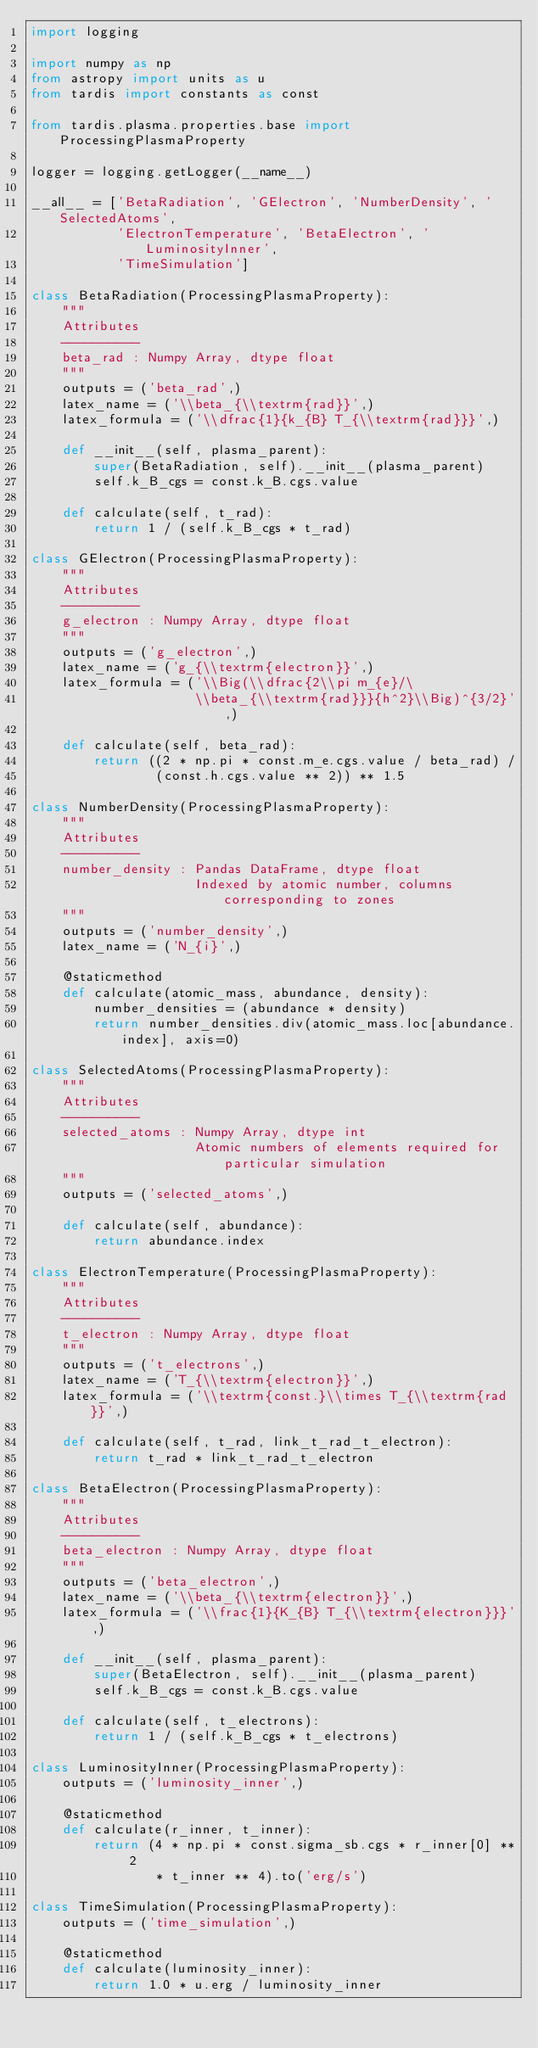<code> <loc_0><loc_0><loc_500><loc_500><_Python_>import logging

import numpy as np
from astropy import units as u
from tardis import constants as const

from tardis.plasma.properties.base import ProcessingPlasmaProperty

logger = logging.getLogger(__name__)

__all__ = ['BetaRadiation', 'GElectron', 'NumberDensity', 'SelectedAtoms',
           'ElectronTemperature', 'BetaElectron', 'LuminosityInner',
           'TimeSimulation']

class BetaRadiation(ProcessingPlasmaProperty):
    """
    Attributes
    ----------
    beta_rad : Numpy Array, dtype float
    """
    outputs = ('beta_rad',)
    latex_name = ('\\beta_{\\textrm{rad}}',)
    latex_formula = ('\\dfrac{1}{k_{B} T_{\\textrm{rad}}}',)

    def __init__(self, plasma_parent):
        super(BetaRadiation, self).__init__(plasma_parent)
        self.k_B_cgs = const.k_B.cgs.value

    def calculate(self, t_rad):
        return 1 / (self.k_B_cgs * t_rad)

class GElectron(ProcessingPlasmaProperty):
    """
    Attributes
    ----------
    g_electron : Numpy Array, dtype float
    """
    outputs = ('g_electron',)
    latex_name = ('g_{\\textrm{electron}}',)
    latex_formula = ('\\Big(\\dfrac{2\\pi m_{e}/\
                     \\beta_{\\textrm{rad}}}{h^2}\\Big)^{3/2}',)

    def calculate(self, beta_rad):
        return ((2 * np.pi * const.m_e.cgs.value / beta_rad) /
                (const.h.cgs.value ** 2)) ** 1.5

class NumberDensity(ProcessingPlasmaProperty):
    """
    Attributes
    ----------
    number_density : Pandas DataFrame, dtype float
                     Indexed by atomic number, columns corresponding to zones
    """
    outputs = ('number_density',)
    latex_name = ('N_{i}',)

    @staticmethod
    def calculate(atomic_mass, abundance, density):
        number_densities = (abundance * density)
        return number_densities.div(atomic_mass.loc[abundance.index], axis=0)

class SelectedAtoms(ProcessingPlasmaProperty):
    """
    Attributes
    ----------
    selected_atoms : Numpy Array, dtype int
                     Atomic numbers of elements required for particular simulation
    """
    outputs = ('selected_atoms',)

    def calculate(self, abundance):
        return abundance.index

class ElectronTemperature(ProcessingPlasmaProperty):
    """
    Attributes
    ----------
    t_electron : Numpy Array, dtype float
    """
    outputs = ('t_electrons',)
    latex_name = ('T_{\\textrm{electron}}',)
    latex_formula = ('\\textrm{const.}\\times T_{\\textrm{rad}}',)

    def calculate(self, t_rad, link_t_rad_t_electron):
        return t_rad * link_t_rad_t_electron

class BetaElectron(ProcessingPlasmaProperty):
    """
    Attributes
    ----------
    beta_electron : Numpy Array, dtype float
    """
    outputs = ('beta_electron',)
    latex_name = ('\\beta_{\\textrm{electron}}',)
    latex_formula = ('\\frac{1}{K_{B} T_{\\textrm{electron}}}',)

    def __init__(self, plasma_parent):
        super(BetaElectron, self).__init__(plasma_parent)
        self.k_B_cgs = const.k_B.cgs.value

    def calculate(self, t_electrons):
        return 1 / (self.k_B_cgs * t_electrons)

class LuminosityInner(ProcessingPlasmaProperty):
    outputs = ('luminosity_inner',)

    @staticmethod
    def calculate(r_inner, t_inner):
        return (4 * np.pi * const.sigma_sb.cgs * r_inner[0] ** 2
                * t_inner ** 4).to('erg/s')

class TimeSimulation(ProcessingPlasmaProperty):
    outputs = ('time_simulation',)

    @staticmethod
    def calculate(luminosity_inner):
        return 1.0 * u.erg / luminosity_inner
</code> 